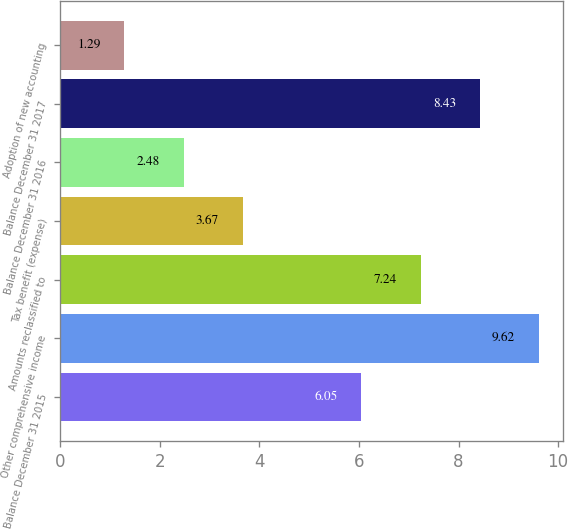Convert chart to OTSL. <chart><loc_0><loc_0><loc_500><loc_500><bar_chart><fcel>Balance December 31 2015<fcel>Other comprehensive income<fcel>Amounts reclassified to<fcel>Tax benefit (expense)<fcel>Balance December 31 2016<fcel>Balance December 31 2017<fcel>Adoption of new accounting<nl><fcel>6.05<fcel>9.62<fcel>7.24<fcel>3.67<fcel>2.48<fcel>8.43<fcel>1.29<nl></chart> 